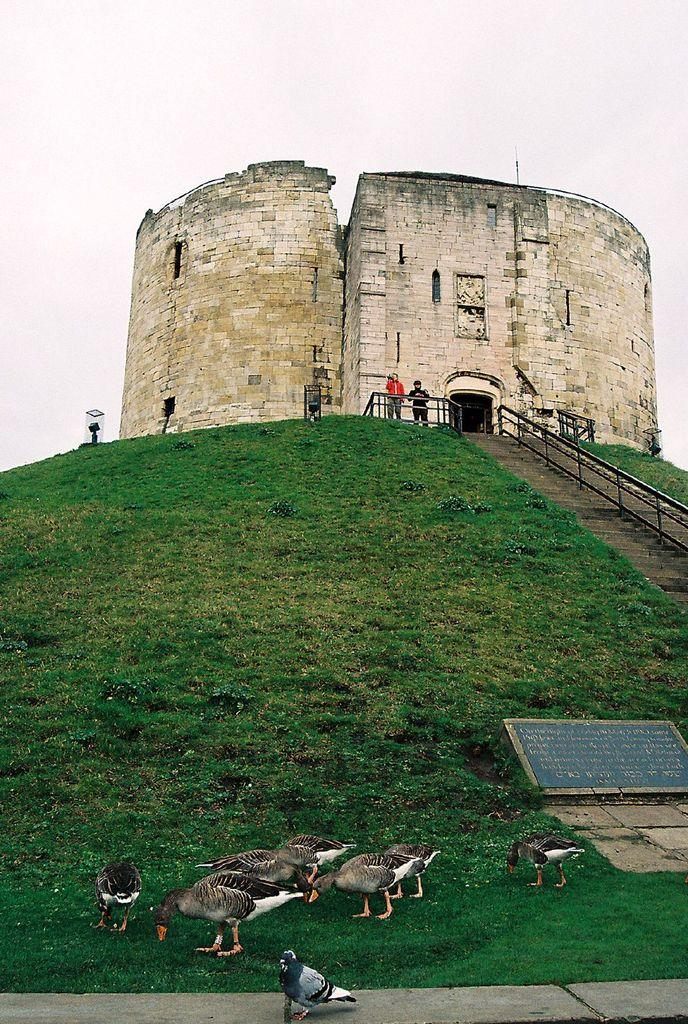What animals can be seen in the foreground of the picture? There are ducks and a pigeon in the foreground of the picture. What type of vegetation is present in the foreground of the picture? There is grass in the foreground of the picture. What can be seen in the center of the picture? There are people, a railing, and a fort in the center of the picture. What is the condition of the sky in the picture? The sky is cloudy in the picture. What type of cart is being used by the people in the picture? There is no cart present in the image; the people are not using any carts. What kind of apparatus is being used by the ducks in the picture? There is no apparatus present in the image; the ducks are not using any apparatus. 